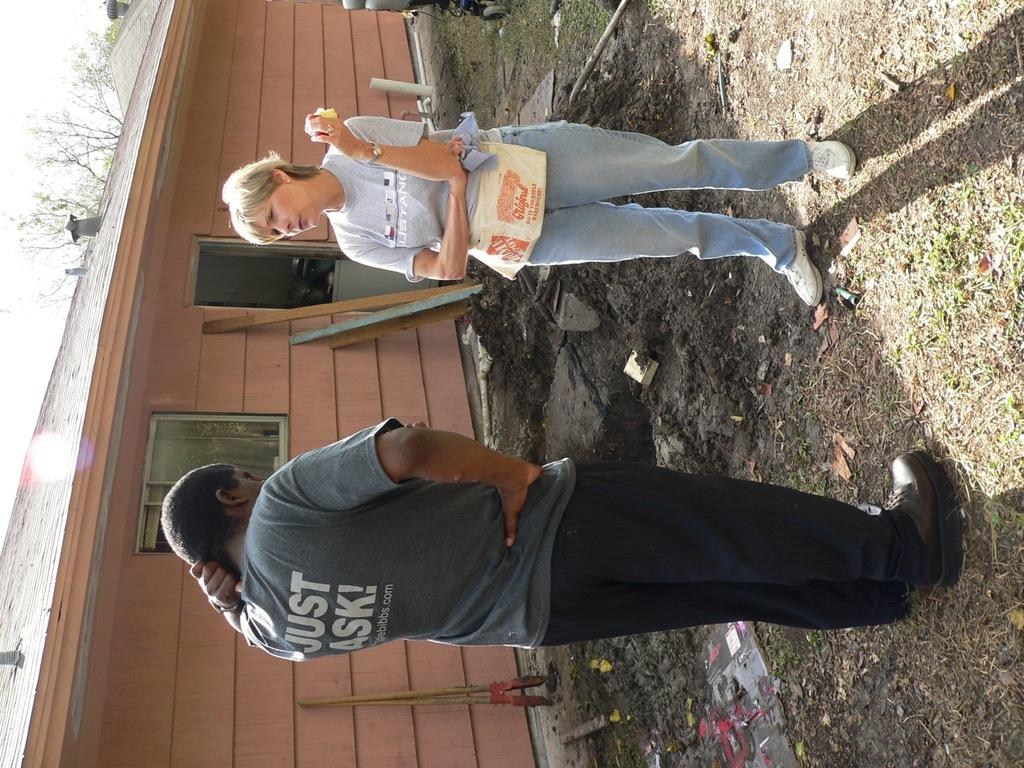Who or what can be seen in the image? There are people in the image. What type of structure is present in the image? There is a house in the image. What can be seen on the ground in the image? The ground is visible in the image with some objects. What materials are present in the image? There are poles and wood in the image. What type of vegetation is visible in the image? There are trees in the image. What part of the natural environment is visible in the image? The sky is visible in the image. How many eyes can be seen on the creature in the image? There is no creature present in the image, so it is not possible to determine the number of eyes. What type of paper is being used by the people in the image? There is no paper visible in the image, so it is not possible to determine what type of paper might be in use. 